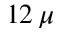<formula> <loc_0><loc_0><loc_500><loc_500>1 2 \, \mu</formula> 